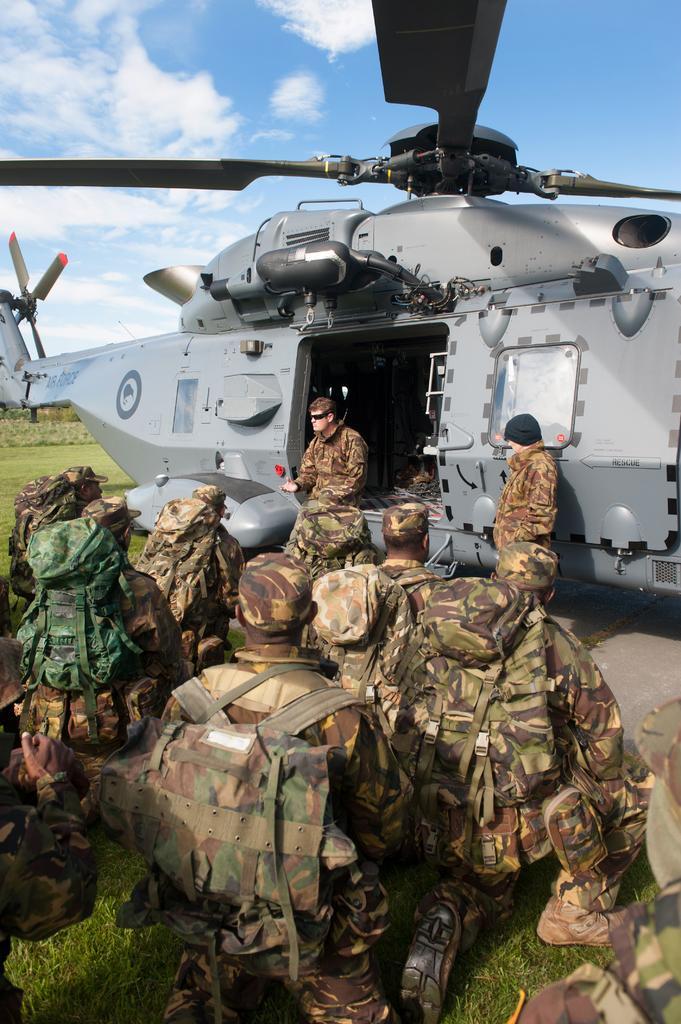Could you give a brief overview of what you see in this image? Here we can see group of people and these people are worn bags. We can see airplane. In the background we can see grass. 